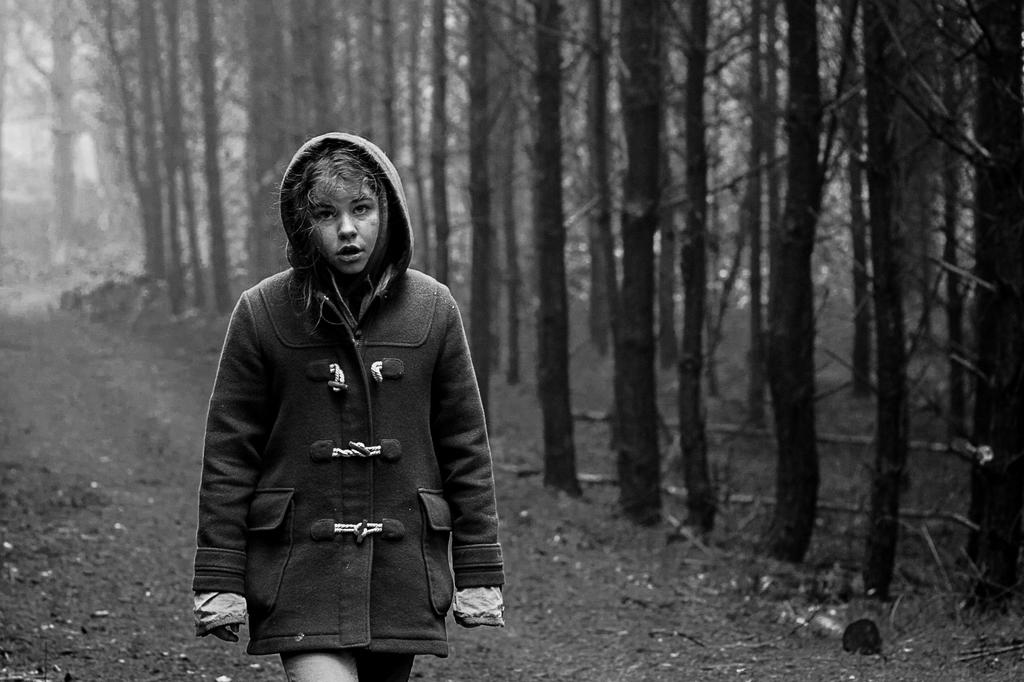Who is the main subject in the image? There is a woman in the image. What is the woman doing in the image? The woman is walking. What is the woman wearing in the image? The woman is wearing a black coat. What type of vegetation can be seen on the right side of the image? There are trees on the right side of the image. What is visible at the bottom of the image? There is a ground visible at the bottom of the image. How many children are accompanying the woman in the image? There are no children present in the image; it only features a woman walking. 